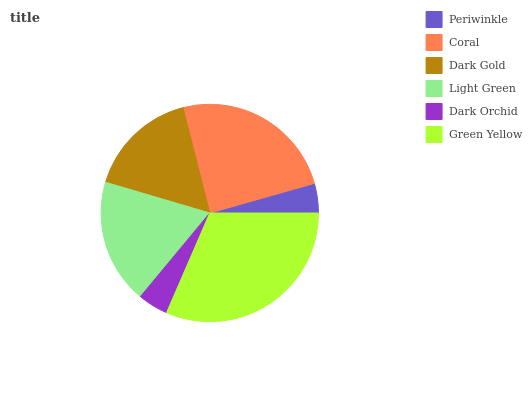Is Periwinkle the minimum?
Answer yes or no. Yes. Is Green Yellow the maximum?
Answer yes or no. Yes. Is Coral the minimum?
Answer yes or no. No. Is Coral the maximum?
Answer yes or no. No. Is Coral greater than Periwinkle?
Answer yes or no. Yes. Is Periwinkle less than Coral?
Answer yes or no. Yes. Is Periwinkle greater than Coral?
Answer yes or no. No. Is Coral less than Periwinkle?
Answer yes or no. No. Is Light Green the high median?
Answer yes or no. Yes. Is Dark Gold the low median?
Answer yes or no. Yes. Is Green Yellow the high median?
Answer yes or no. No. Is Light Green the low median?
Answer yes or no. No. 